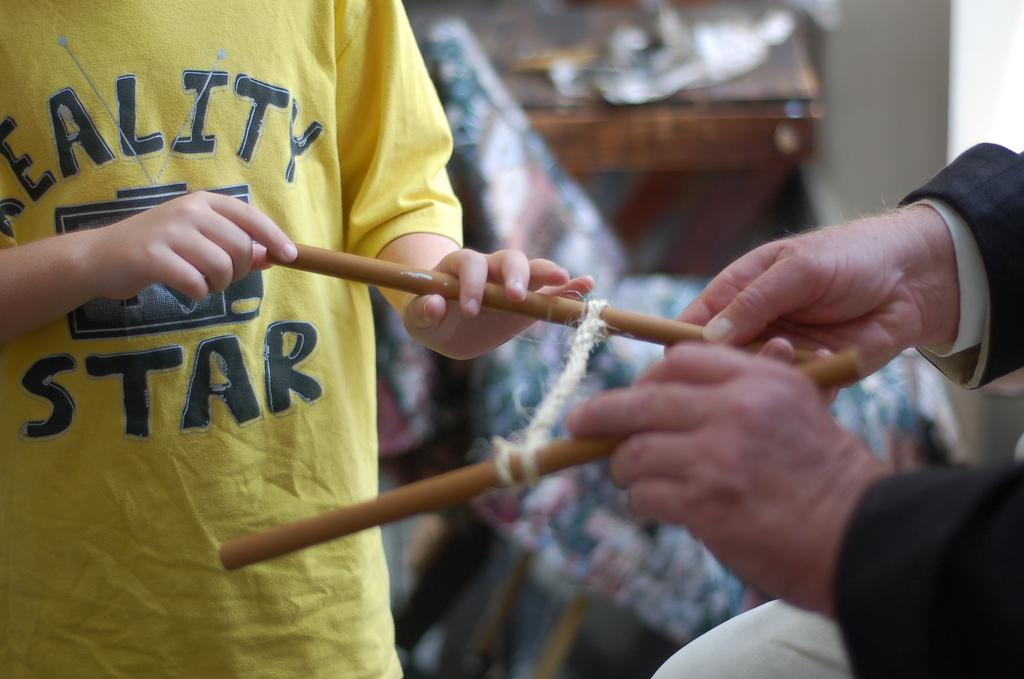What does his shirt say?
Your answer should be compact. Reality star. 